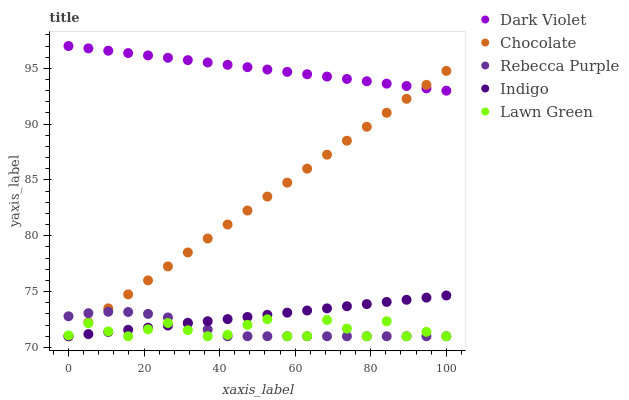Does Lawn Green have the minimum area under the curve?
Answer yes or no. Yes. Does Dark Violet have the maximum area under the curve?
Answer yes or no. Yes. Does Indigo have the minimum area under the curve?
Answer yes or no. No. Does Indigo have the maximum area under the curve?
Answer yes or no. No. Is Dark Violet the smoothest?
Answer yes or no. Yes. Is Lawn Green the roughest?
Answer yes or no. Yes. Is Indigo the smoothest?
Answer yes or no. No. Is Indigo the roughest?
Answer yes or no. No. Does Lawn Green have the lowest value?
Answer yes or no. Yes. Does Dark Violet have the lowest value?
Answer yes or no. No. Does Dark Violet have the highest value?
Answer yes or no. Yes. Does Indigo have the highest value?
Answer yes or no. No. Is Indigo less than Dark Violet?
Answer yes or no. Yes. Is Dark Violet greater than Indigo?
Answer yes or no. Yes. Does Indigo intersect Lawn Green?
Answer yes or no. Yes. Is Indigo less than Lawn Green?
Answer yes or no. No. Is Indigo greater than Lawn Green?
Answer yes or no. No. Does Indigo intersect Dark Violet?
Answer yes or no. No. 